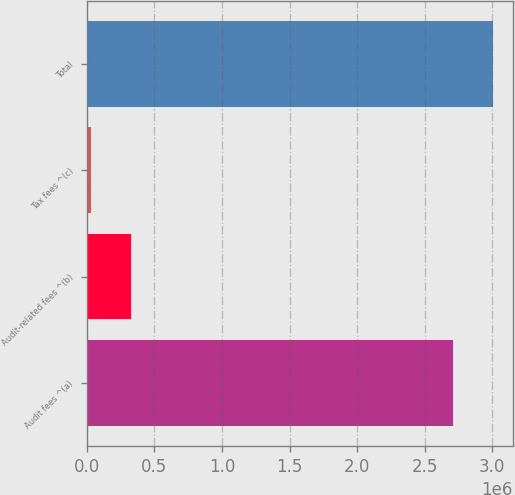Convert chart. <chart><loc_0><loc_0><loc_500><loc_500><bar_chart><fcel>Audit fees ^(a)<fcel>Audit-related fees ^(b)<fcel>Tax fees ^(c)<fcel>Total<nl><fcel>2.706e+06<fcel>326200<fcel>30000<fcel>3.0022e+06<nl></chart> 